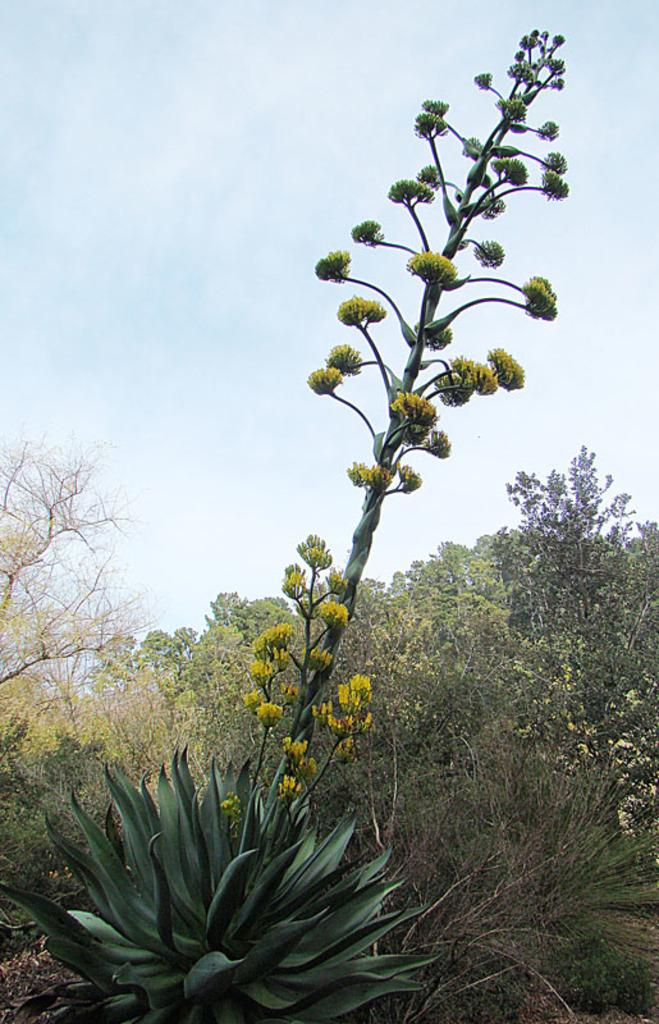What is the main subject in the center of the image? There is a plant in the center of the image. What can be seen in the background of the image? There are trees and the sky visible in the background of the image. What is the taste of the plant in the image? The taste of the plant cannot be determined from the image, as taste is not a visual characteristic. 